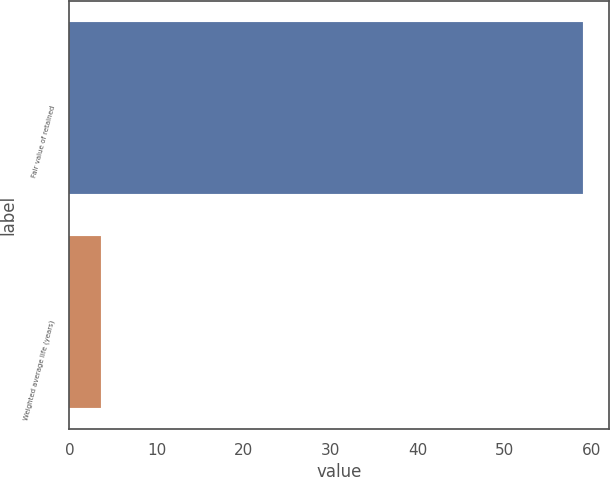Convert chart to OTSL. <chart><loc_0><loc_0><loc_500><loc_500><bar_chart><fcel>Fair value of retained<fcel>Weighted average life (years)<nl><fcel>59<fcel>3.6<nl></chart> 